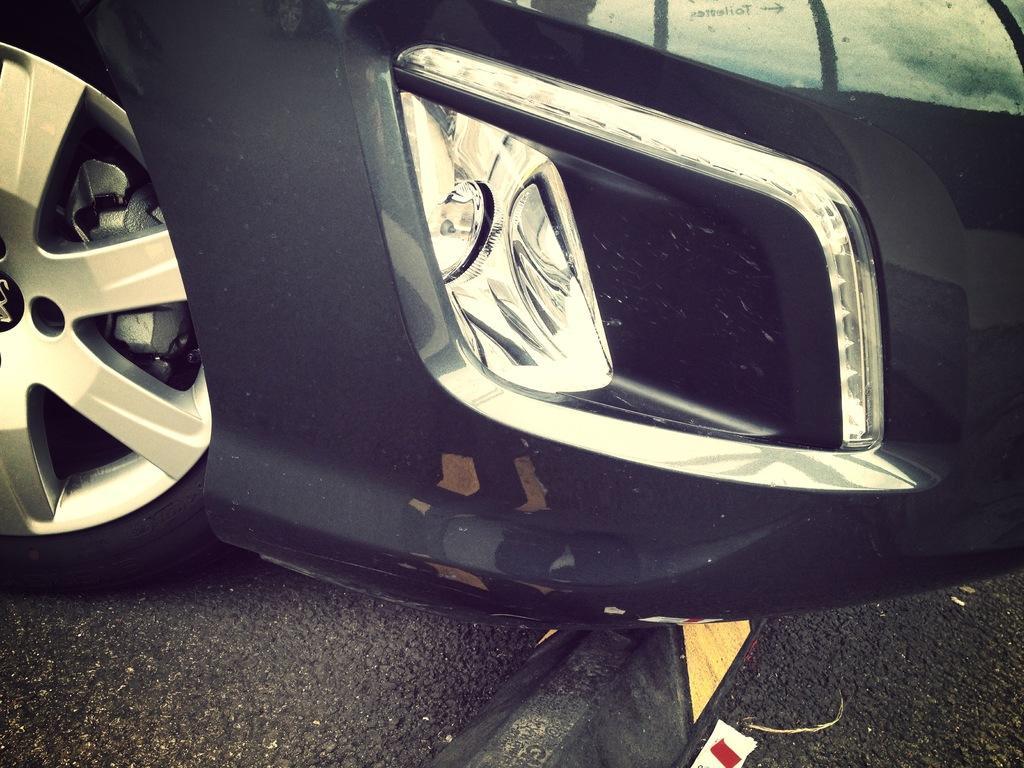Describe this image in one or two sentences. In the center of the image there is a car tyre and fog light. At the bottom of the image there is road. 